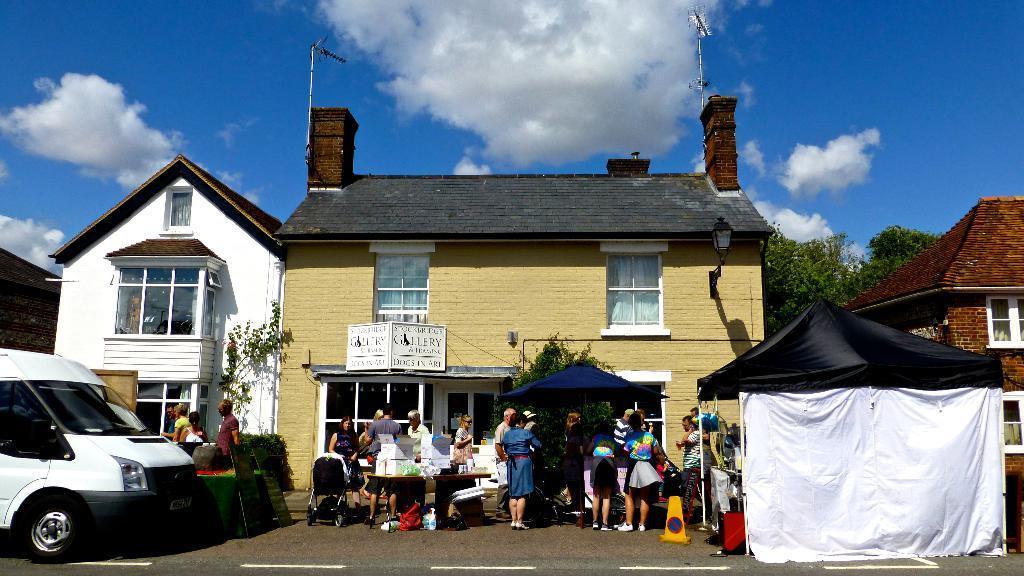Describe this image in one or two sentences. In the picture we can see a house with a shop and some people are standing near it and on the top of the shop we can see two glass windows and beside the house we can see another house which is white in color and two glass windows to it and near to it we can see two people are standing and we can also see a van which is white in color parked near it and on the right side of the house we can see a black color tent with white color curtain and behind it we can see a house which is brown in color with window to it and behind it we can see tree and the sky with clouds. 